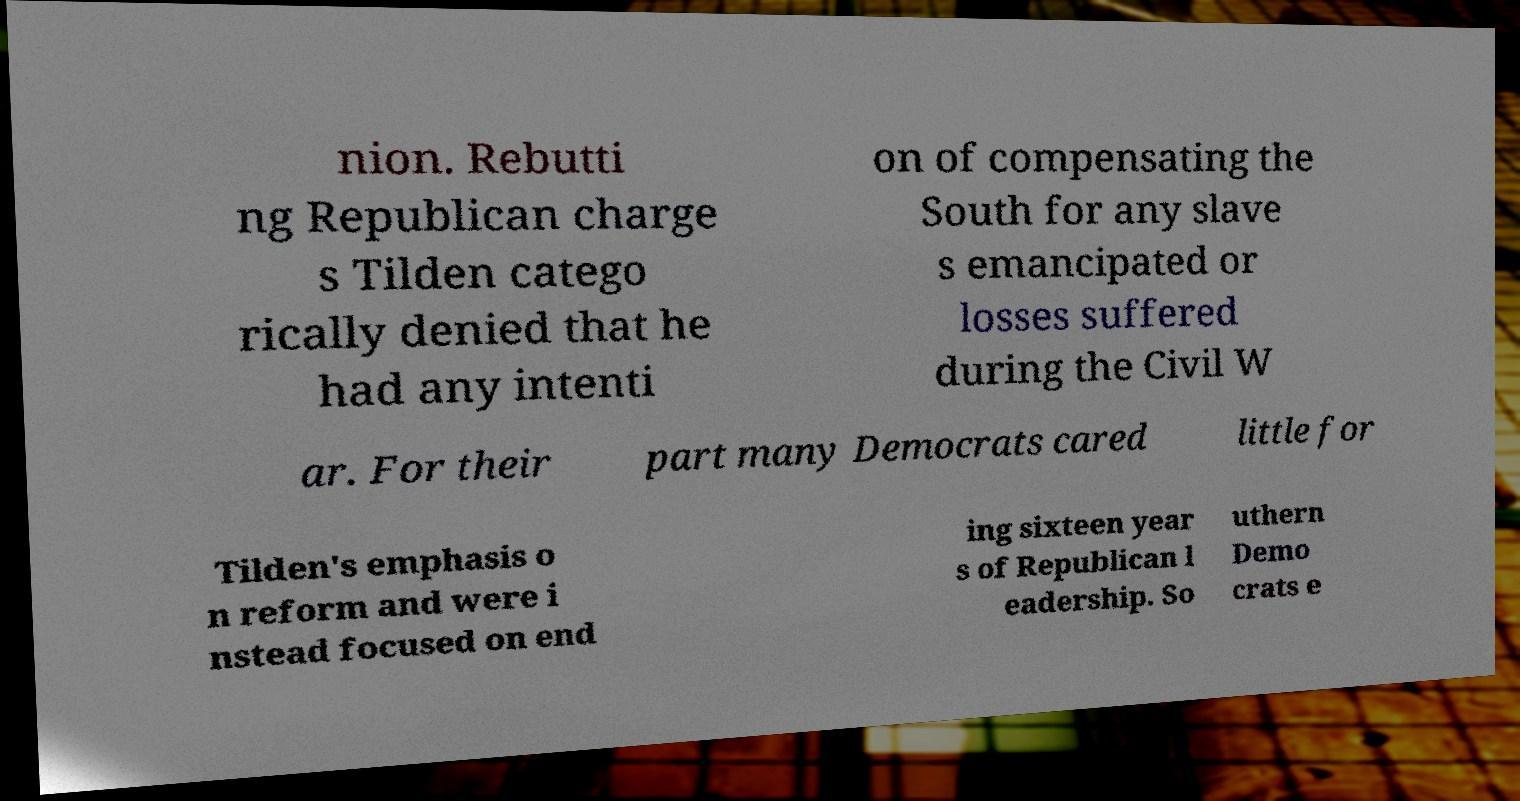What messages or text are displayed in this image? I need them in a readable, typed format. nion. Rebutti ng Republican charge s Tilden catego rically denied that he had any intenti on of compensating the South for any slave s emancipated or losses suffered during the Civil W ar. For their part many Democrats cared little for Tilden's emphasis o n reform and were i nstead focused on end ing sixteen year s of Republican l eadership. So uthern Demo crats e 